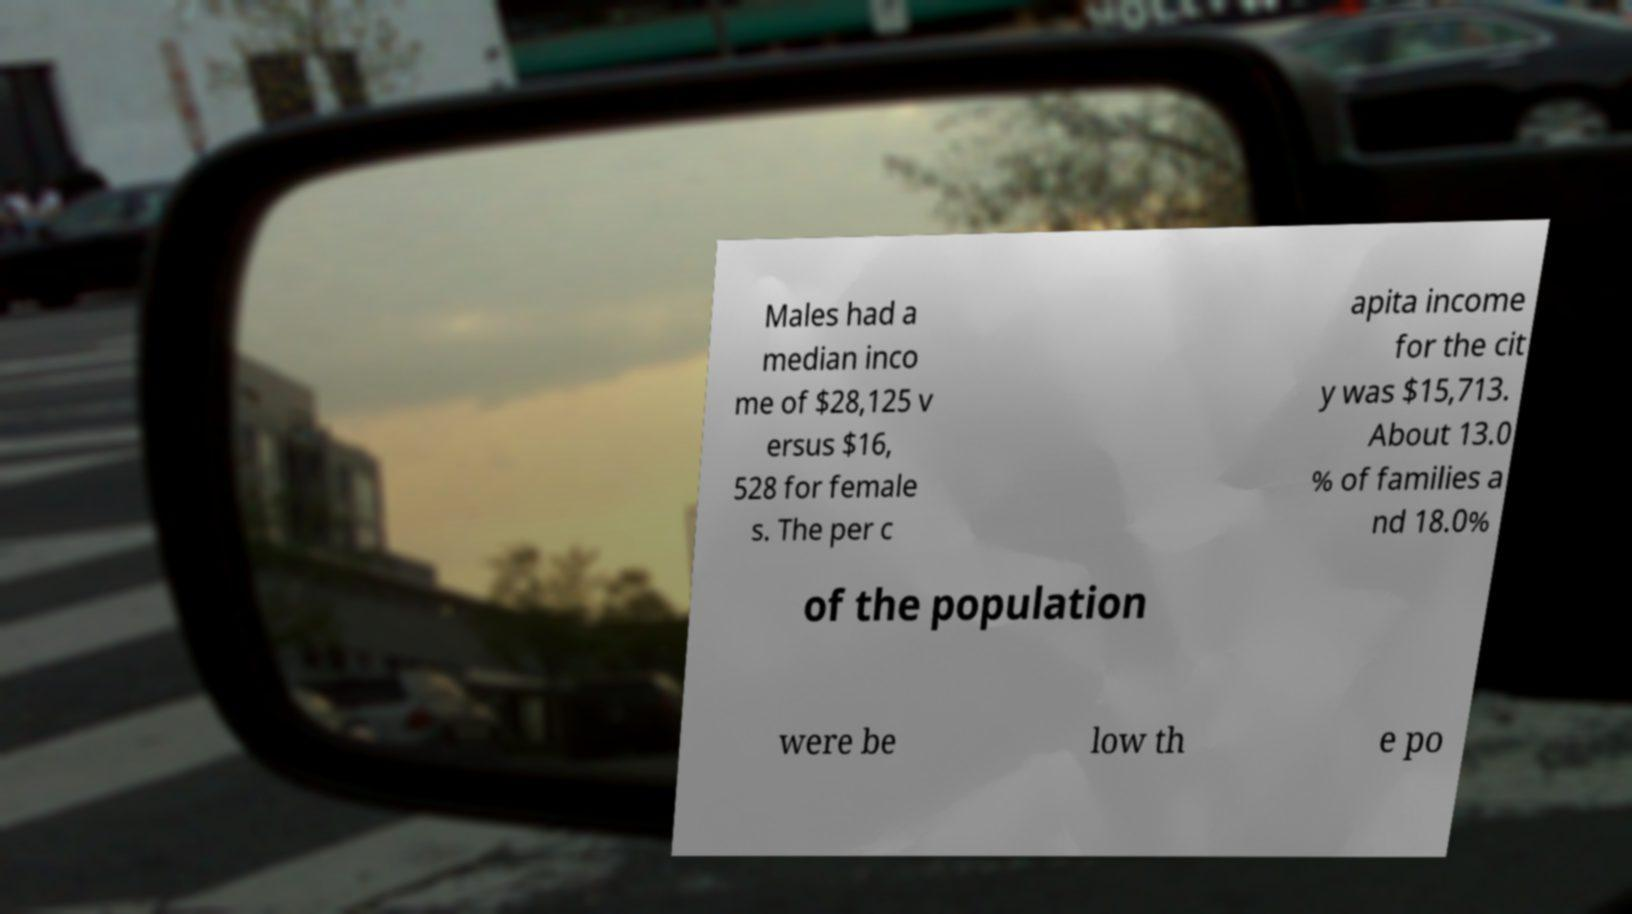Could you extract and type out the text from this image? Males had a median inco me of $28,125 v ersus $16, 528 for female s. The per c apita income for the cit y was $15,713. About 13.0 % of families a nd 18.0% of the population were be low th e po 